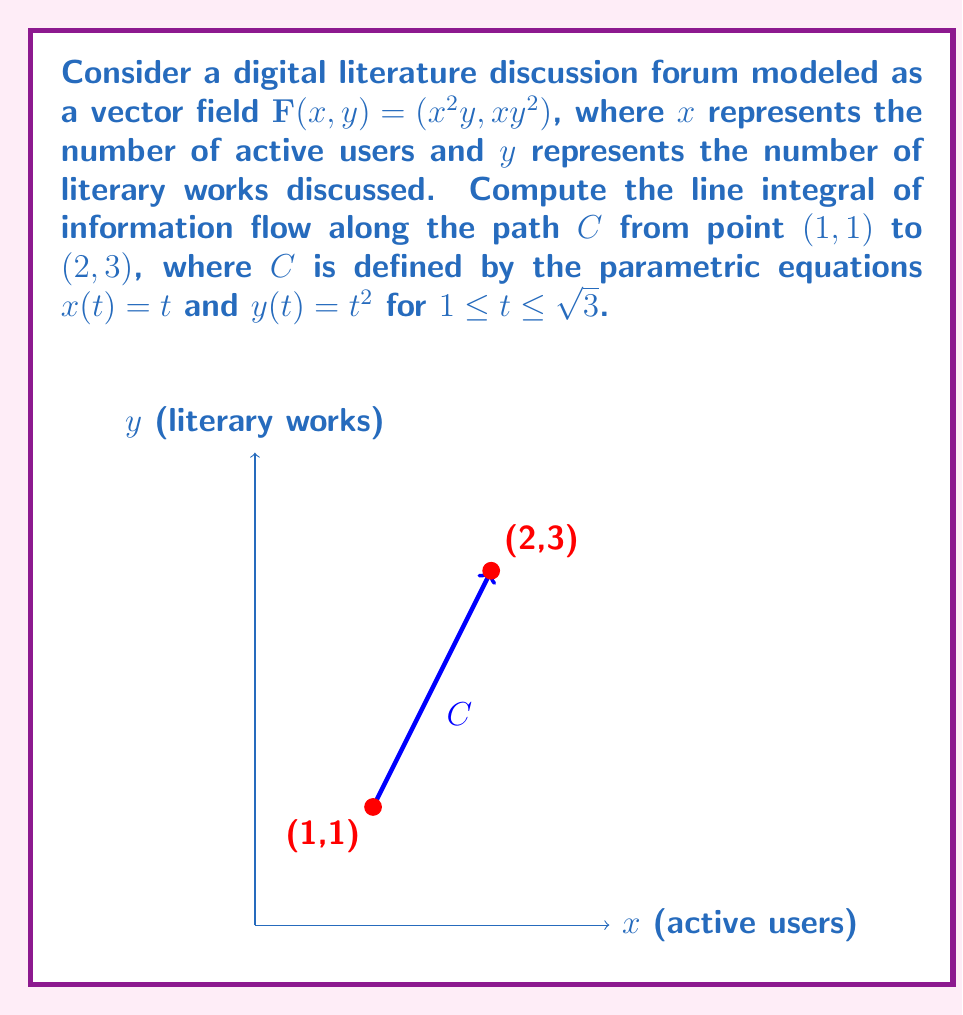Give your solution to this math problem. To compute the line integral, we'll follow these steps:

1) The line integral is given by:
   $$\int_C \mathbf{F} \cdot d\mathbf{r} = \int_a^b \mathbf{F}(x(t),y(t)) \cdot \left(\frac{dx}{dt}, \frac{dy}{dt}\right) dt$$

2) We have $\mathbf{F}(x,y) = (x^2y, xy^2)$, $x(t) = t$, and $y(t) = t^2$.

3) Calculate $\frac{dx}{dt}$ and $\frac{dy}{dt}$:
   $\frac{dx}{dt} = 1$ and $\frac{dy}{dt} = 2t$

4) Substitute into the integral:
   $$\int_1^{\sqrt{3}} (t^2(t^2), t(t^2)^2) \cdot (1, 2t) dt$$

5) Simplify:
   $$\int_1^{\sqrt{3}} (t^4 + 2t^5) dt$$

6) Integrate:
   $$\left[\frac{t^5}{5} + \frac{t^6}{3}\right]_1^{\sqrt{3}}$$

7) Evaluate the limits:
   $$\left(\frac{(\sqrt{3})^5}{5} + \frac{(\sqrt{3})^6}{3}\right) - \left(\frac{1^5}{5} + \frac{1^6}{3}\right)$$

8) Simplify:
   $$\frac{3\sqrt{3}}{5} + 3 - \frac{1}{5} - \frac{1}{3} = \frac{3\sqrt{3}}{5} + \frac{13}{5}$$
Answer: $\frac{3\sqrt{3}}{5} + \frac{13}{5}$ 